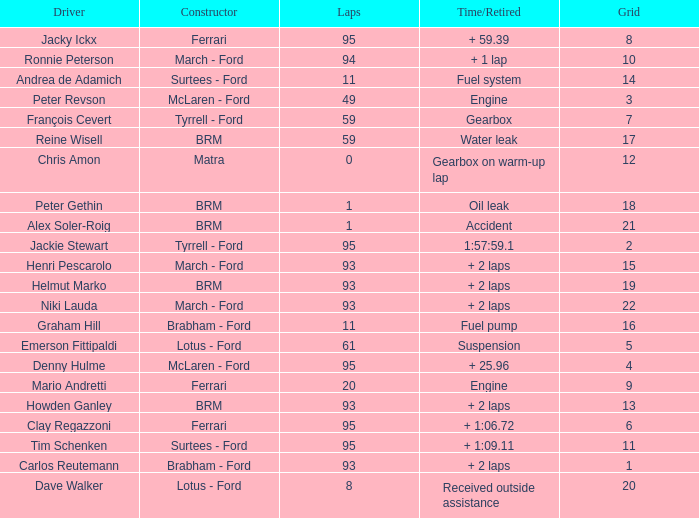How many grids does dave walker have? 1.0. 